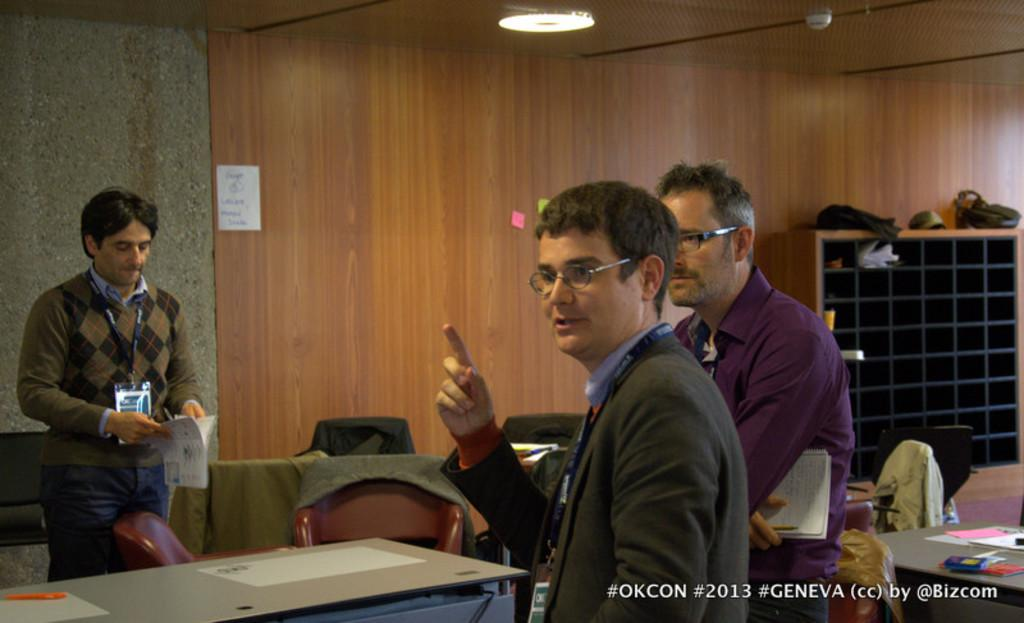How many people are in the image? There are three persons standing in the image. Can you describe the appearance of the persons? Two of the persons are wearing spectacles. What type of furniture is present in the image? There are tables and chairs in the image. What type of bird can be seen flying over the club in the image? There is no bird or club present in the image; it only features three persons standing and some furniture. Is there any indication of payment being made in the image? There is no indication of payment being made in the image. 